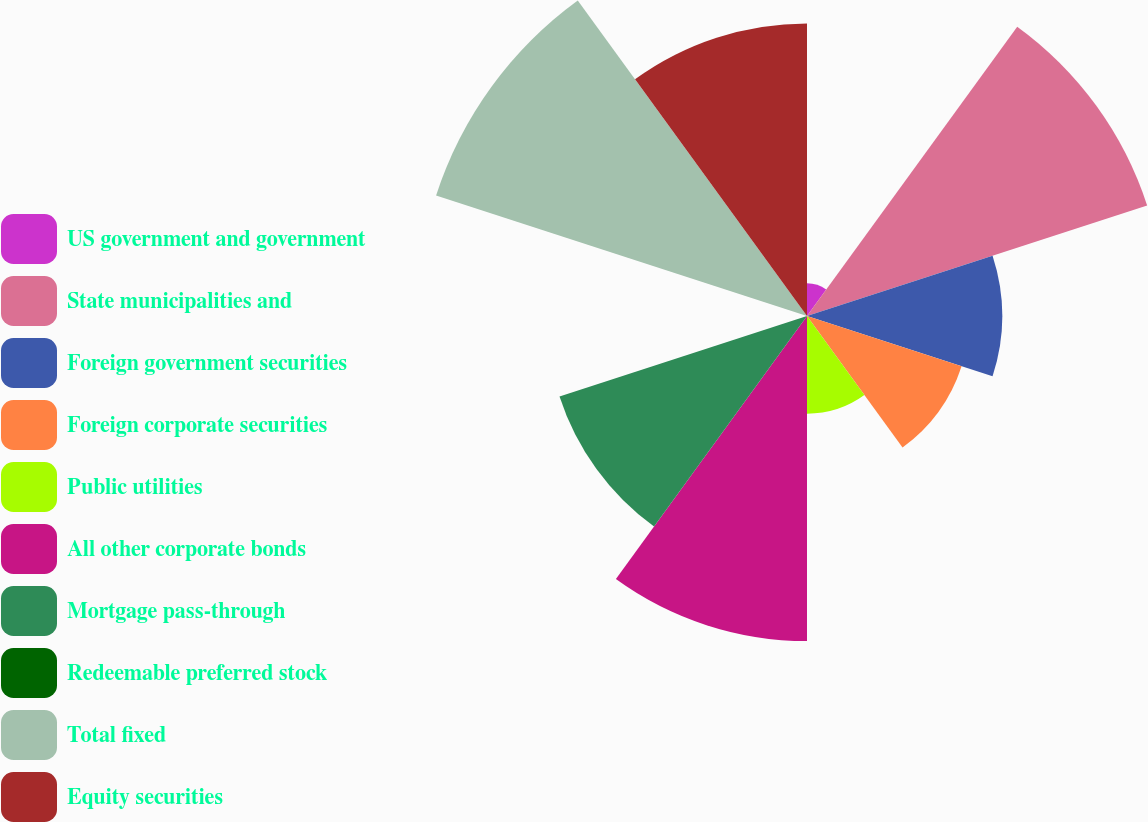Convert chart to OTSL. <chart><loc_0><loc_0><loc_500><loc_500><pie_chart><fcel>US government and government<fcel>State municipalities and<fcel>Foreign government securities<fcel>Foreign corporate securities<fcel>Public utilities<fcel>All other corporate bonds<fcel>Mortgage pass-through<fcel>Redeemable preferred stock<fcel>Total fixed<fcel>Equity securities<nl><fcel>1.55%<fcel>16.92%<fcel>9.23%<fcel>7.69%<fcel>4.62%<fcel>15.38%<fcel>12.31%<fcel>0.01%<fcel>18.45%<fcel>13.84%<nl></chart> 